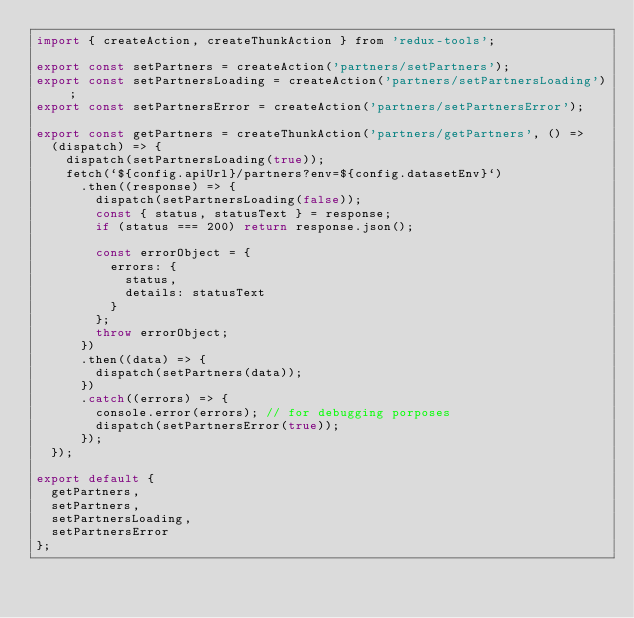<code> <loc_0><loc_0><loc_500><loc_500><_JavaScript_>import { createAction, createThunkAction } from 'redux-tools';

export const setPartners = createAction('partners/setPartners');
export const setPartnersLoading = createAction('partners/setPartnersLoading');
export const setPartnersError = createAction('partners/setPartnersError');

export const getPartners = createThunkAction('partners/getPartners', () =>
  (dispatch) => {
    dispatch(setPartnersLoading(true));
    fetch(`${config.apiUrl}/partners?env=${config.datasetEnv}`)
      .then((response) => {
        dispatch(setPartnersLoading(false));
        const { status, statusText } = response;
        if (status === 200) return response.json();

        const errorObject = {
          errors: {
            status,
            details: statusText
          }
        };
        throw errorObject;
      })
      .then((data) => {
        dispatch(setPartners(data));
      })
      .catch((errors) => {
        console.error(errors); // for debugging porposes
        dispatch(setPartnersError(true));
      });
  });

export default {
  getPartners,
  setPartners,
  setPartnersLoading,
  setPartnersError
};
</code> 